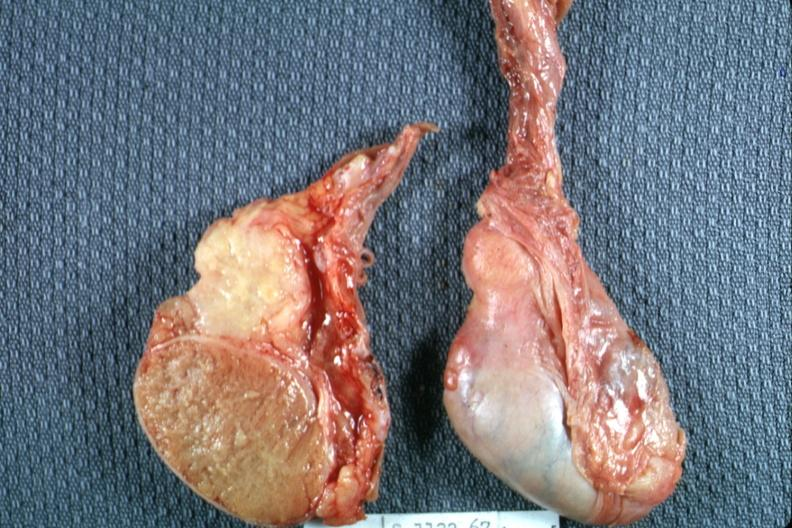what does this image show?
Answer the question using a single word or phrase. Excellent view of cut surface and unopened surface 